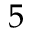Convert formula to latex. <formula><loc_0><loc_0><loc_500><loc_500>5</formula> 